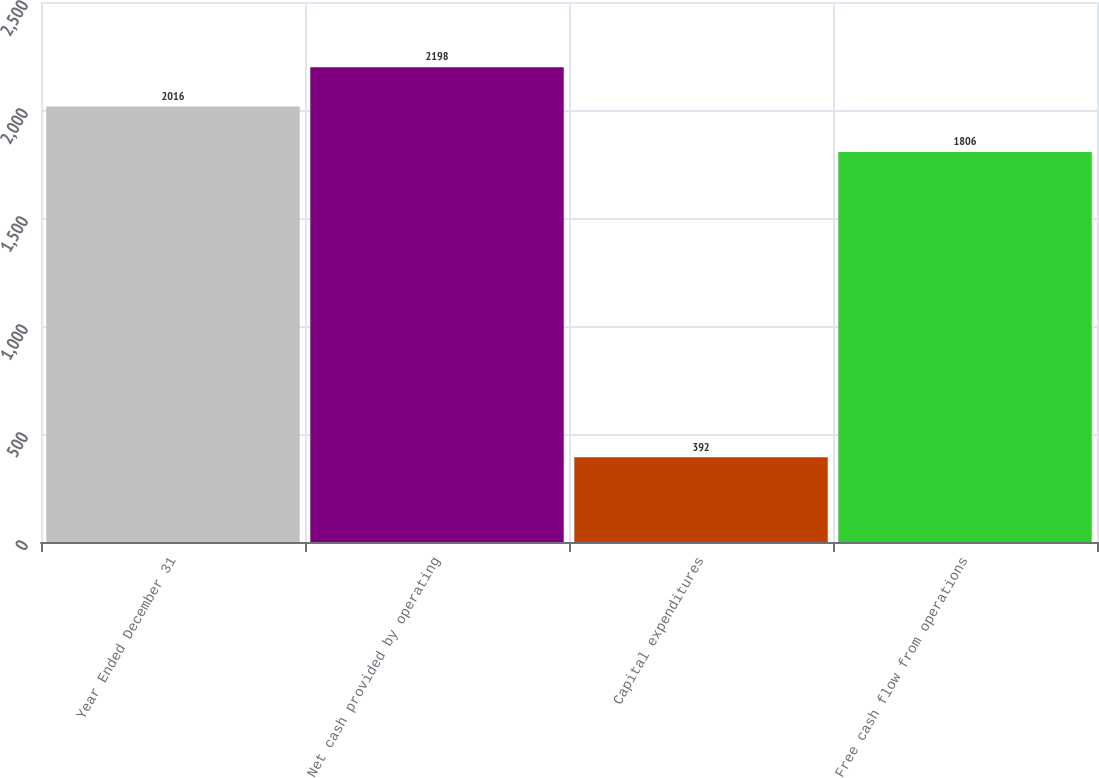<chart> <loc_0><loc_0><loc_500><loc_500><bar_chart><fcel>Year Ended December 31<fcel>Net cash provided by operating<fcel>Capital expenditures<fcel>Free cash flow from operations<nl><fcel>2016<fcel>2198<fcel>392<fcel>1806<nl></chart> 